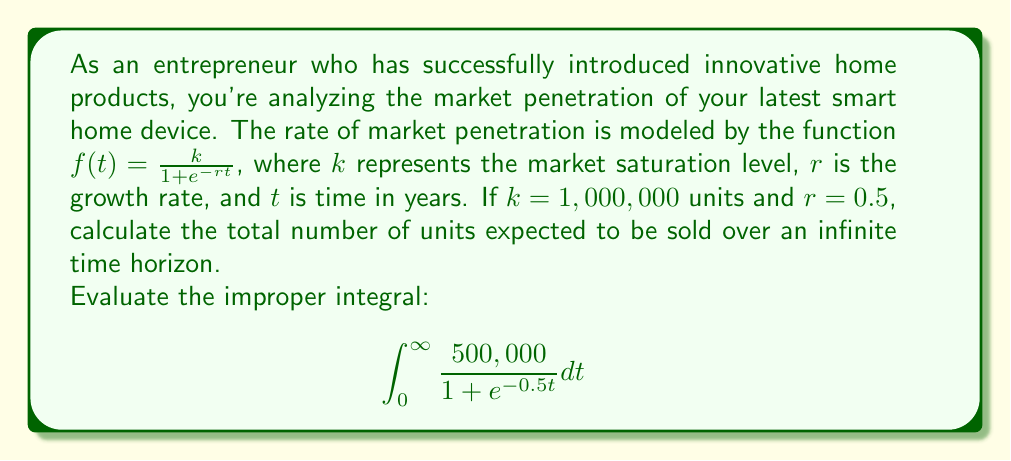Show me your answer to this math problem. Let's approach this step-by-step:

1) We need to evaluate the improper integral:

   $$\int_0^{\infty} \frac{500,000}{1 + e^{-0.5t}} dt$$

2) This integral doesn't have an elementary antiderivative, but we can solve it using a substitution method.

3) Let $u = e^{-0.5t}$. Then $du = -0.5e^{-0.5t}dt$, or $dt = -\frac{2}{u}du$.

4) When $t = 0$, $u = e^0 = 1$. When $t \to \infty$, $u \to 0$.

5) Substituting:

   $$\int_1^0 \frac{500,000}{1 + u} \cdot (-\frac{2}{u}) du$$

6) Simplifying:

   $$-1,000,000 \int_1^0 \frac{1}{u(1 + u)} du$$

7) This can be solved using partial fractions:

   $$\frac{1}{u(1 + u)} = \frac{1}{u} - \frac{1}{1+u}$$

8) So our integral becomes:

   $$-1,000,000 \int_1^0 (\frac{1}{u} - \frac{1}{1+u}) du$$

9) Evaluating:

   $$-1,000,000 [(\ln|u| - \ln|1+u|)]_1^0$$

10) At the lower limit (u = 1):
    
    $$-1,000,000 [(\ln 1 - \ln 2)] = 1,000,000 \ln 2$$

11) At the upper limit (u → 0):
    
    $$\lim_{u \to 0} -1,000,000 [(\ln u - \ln(1+u))]$$
    
    The $\ln u$ term goes to $-\infty$, but it's negated, so it becomes $+\infty$.

12) Therefore, the total integral is:

    $$\infty - 1,000,000 \ln 2$$

13) The infinite term dominates, so the final result is $\infty$.
Answer: $\infty$ units 